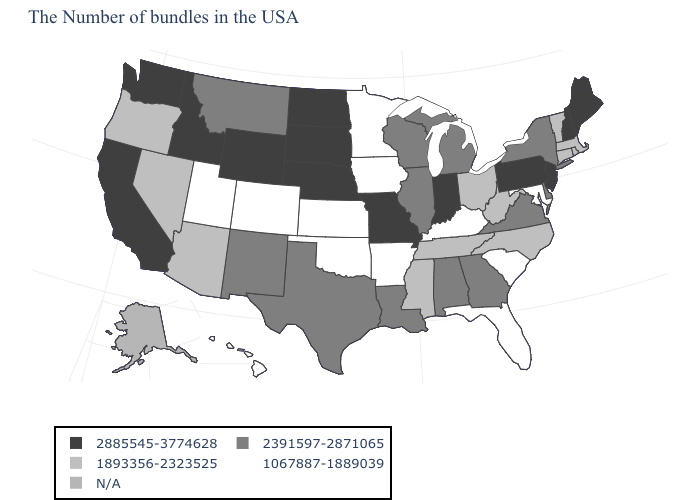Name the states that have a value in the range N/A?
Short answer required. Alaska. What is the value of Oklahoma?
Give a very brief answer. 1067887-1889039. Which states have the highest value in the USA?
Be succinct. Maine, New Hampshire, New Jersey, Pennsylvania, Indiana, Missouri, Nebraska, South Dakota, North Dakota, Wyoming, Idaho, California, Washington. What is the value of Indiana?
Short answer required. 2885545-3774628. Name the states that have a value in the range 2885545-3774628?
Write a very short answer. Maine, New Hampshire, New Jersey, Pennsylvania, Indiana, Missouri, Nebraska, South Dakota, North Dakota, Wyoming, Idaho, California, Washington. Name the states that have a value in the range 2391597-2871065?
Be succinct. New York, Delaware, Virginia, Georgia, Michigan, Alabama, Wisconsin, Illinois, Louisiana, Texas, New Mexico, Montana. What is the highest value in the USA?
Write a very short answer. 2885545-3774628. What is the value of Nevada?
Short answer required. 1893356-2323525. What is the highest value in states that border Maryland?
Give a very brief answer. 2885545-3774628. What is the value of Georgia?
Be succinct. 2391597-2871065. Does Maine have the highest value in the Northeast?
Answer briefly. Yes. Name the states that have a value in the range 2391597-2871065?
Concise answer only. New York, Delaware, Virginia, Georgia, Michigan, Alabama, Wisconsin, Illinois, Louisiana, Texas, New Mexico, Montana. Does the map have missing data?
Write a very short answer. Yes. Name the states that have a value in the range 1067887-1889039?
Short answer required. Maryland, South Carolina, Florida, Kentucky, Arkansas, Minnesota, Iowa, Kansas, Oklahoma, Colorado, Utah, Hawaii. What is the value of Massachusetts?
Short answer required. 1893356-2323525. 